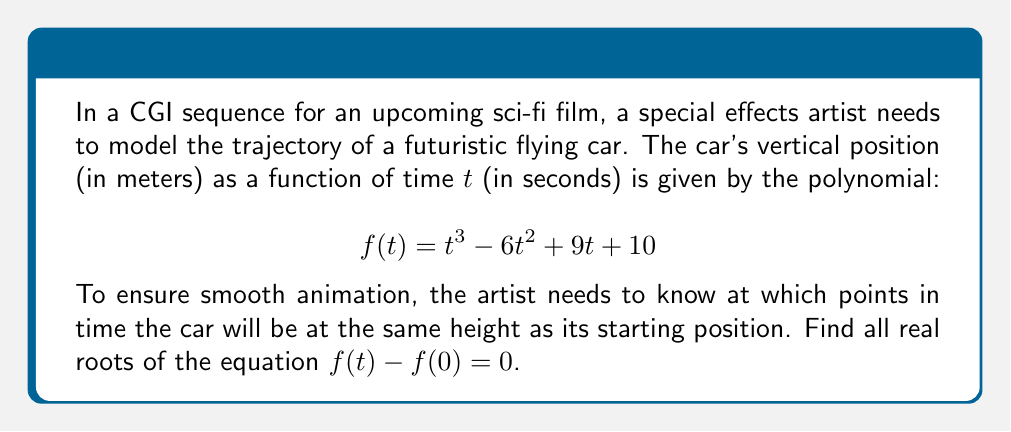Show me your answer to this math problem. Let's approach this step-by-step:

1) First, we need to find $f(0)$, which is the starting height:
   $$f(0) = 0^3 - 6(0)^2 + 9(0) + 10 = 10$$

2) Now, we set up the equation $f(t) - f(0) = 0$:
   $$t^3 - 6t^2 + 9t + 10 - 10 = 0$$

3) Simplify:
   $$t^3 - 6t^2 + 9t = 0$$

4) Factor out the greatest common factor:
   $$t(t^2 - 6t + 9) = 0$$

5) Use the zero product property. Either $t = 0$ or $t^2 - 6t + 9 = 0$

6) For the quadratic equation $t^2 - 6t + 9 = 0$, we can use the quadratic formula:
   $$t = \frac{-b \pm \sqrt{b^2 - 4ac}}{2a}$$
   where $a = 1$, $b = -6$, and $c = 9$

7) Substituting these values:
   $$t = \frac{6 \pm \sqrt{36 - 36}}{2} = \frac{6 \pm 0}{2} = 3$$

8) Therefore, the quadratic equation has a double root at $t = 3$

9) Combining this with the solution from step 5, we have three roots: $t = 0$ and $t = 3$ (twice)
Answer: The real roots are $t = 0$ and $t = 3$ (double root). 